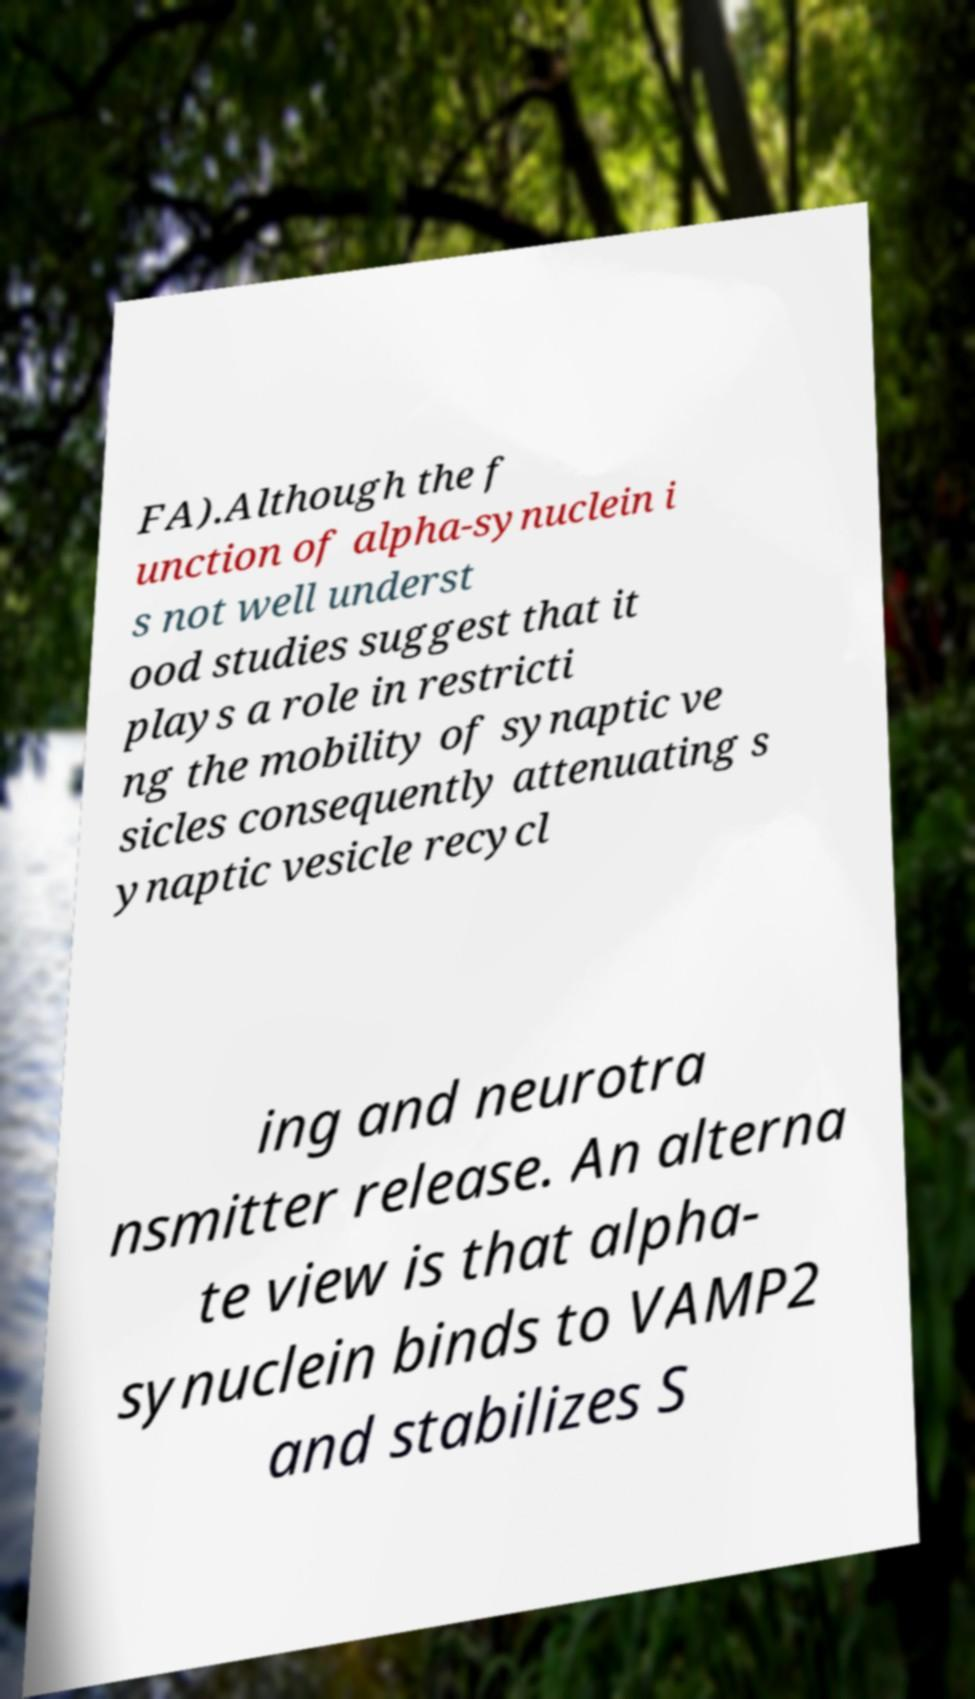Could you extract and type out the text from this image? FA).Although the f unction of alpha-synuclein i s not well underst ood studies suggest that it plays a role in restricti ng the mobility of synaptic ve sicles consequently attenuating s ynaptic vesicle recycl ing and neurotra nsmitter release. An alterna te view is that alpha- synuclein binds to VAMP2 and stabilizes S 